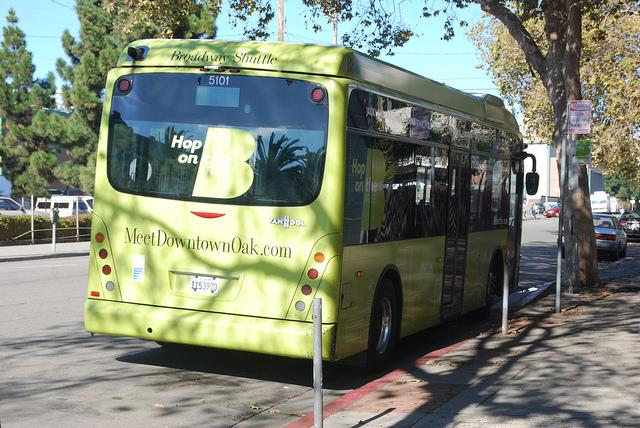What city is this?

Choices:
A) chicago
B) fremont
C) oakland
D) broadway oakland 